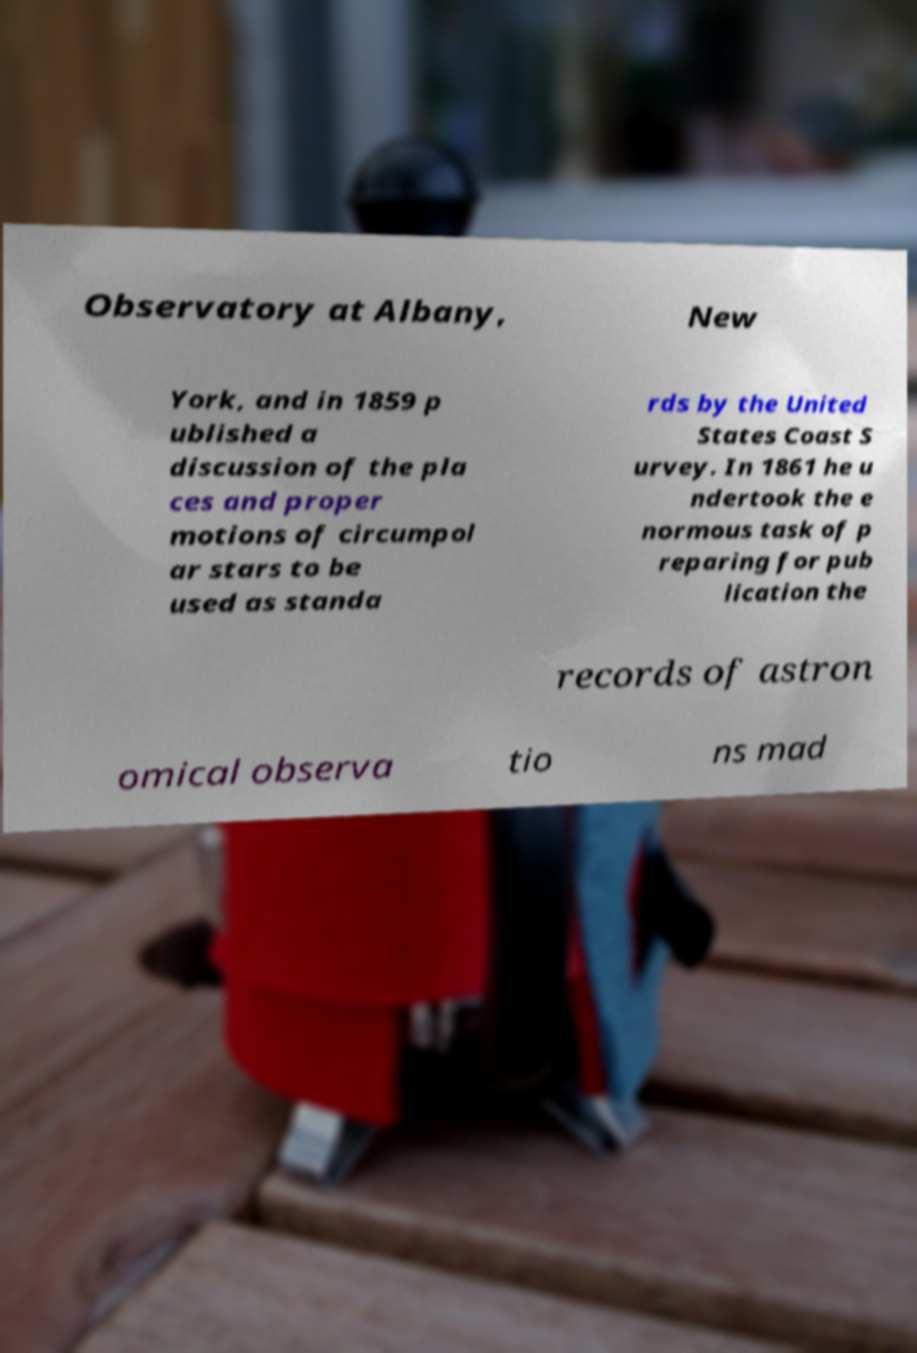Please identify and transcribe the text found in this image. Observatory at Albany, New York, and in 1859 p ublished a discussion of the pla ces and proper motions of circumpol ar stars to be used as standa rds by the United States Coast S urvey. In 1861 he u ndertook the e normous task of p reparing for pub lication the records of astron omical observa tio ns mad 